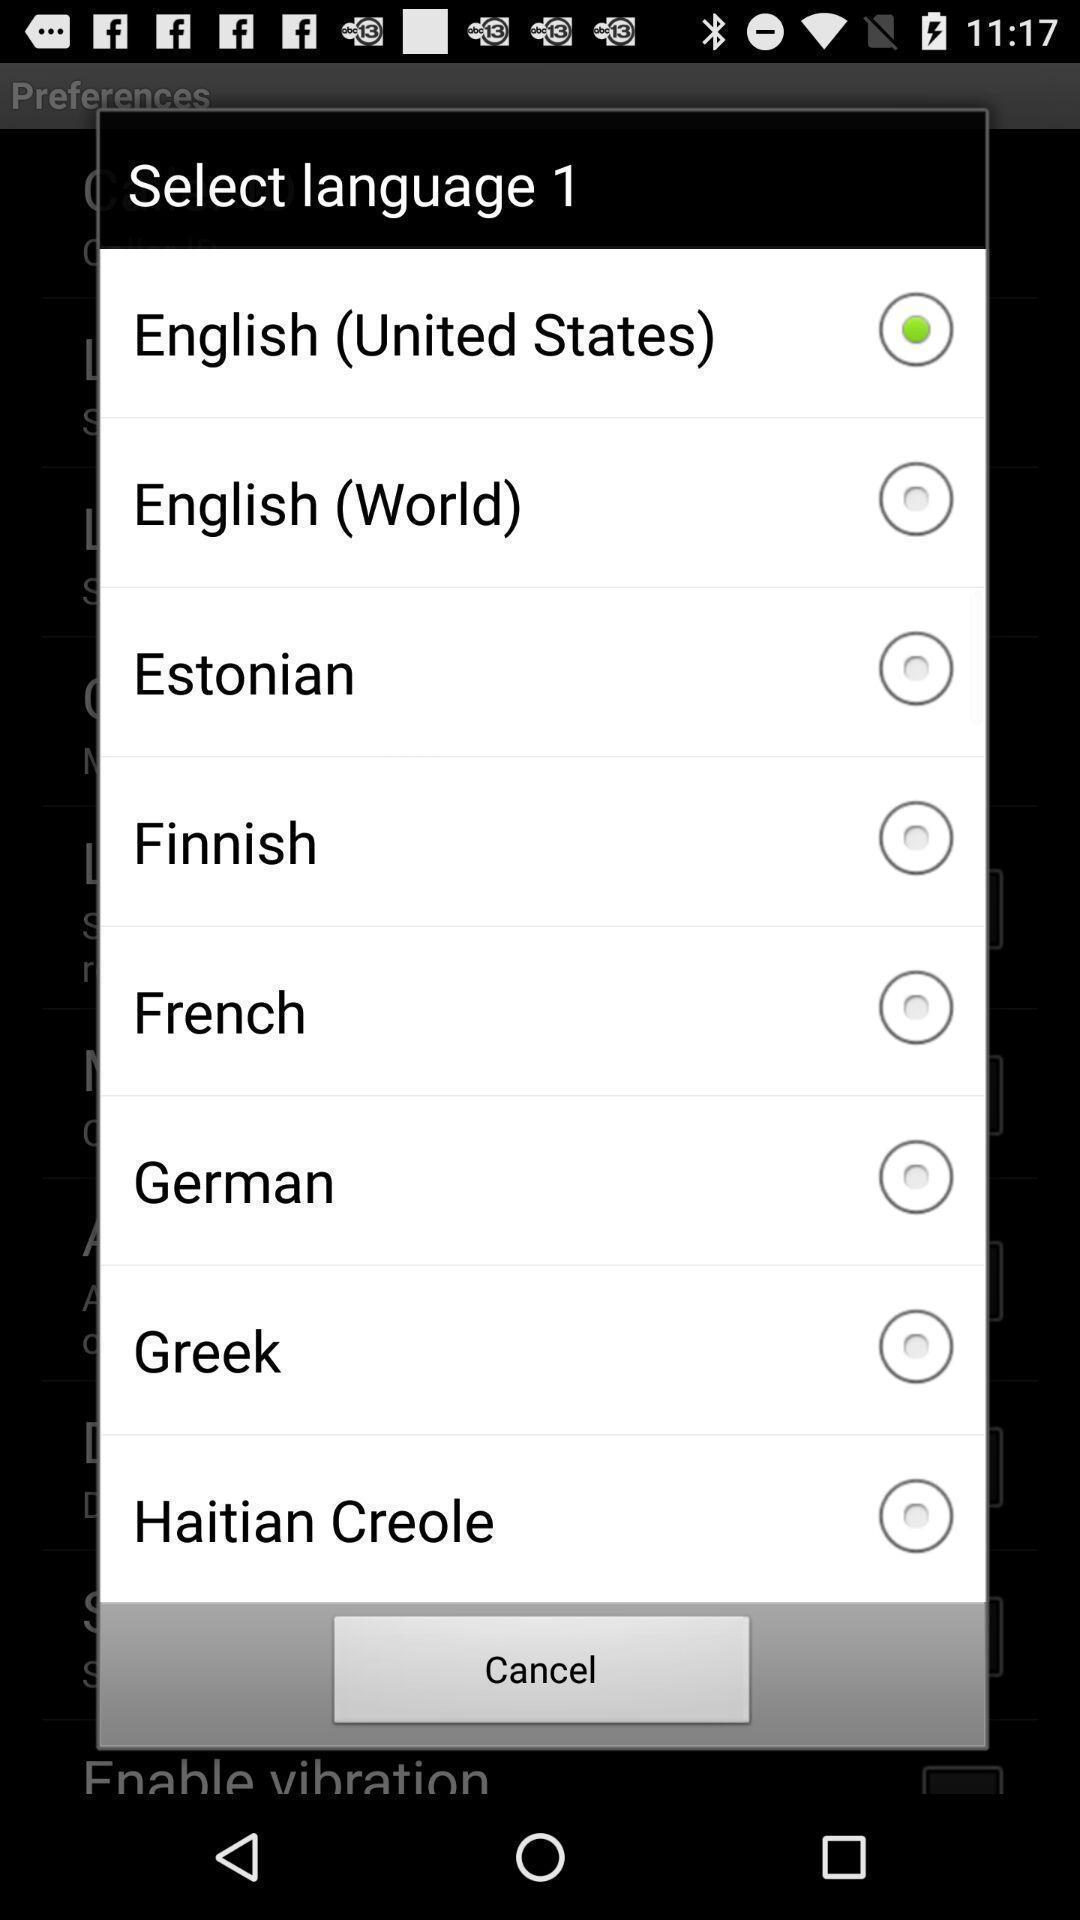Provide a description of this screenshot. Push-up showing list of languages. 